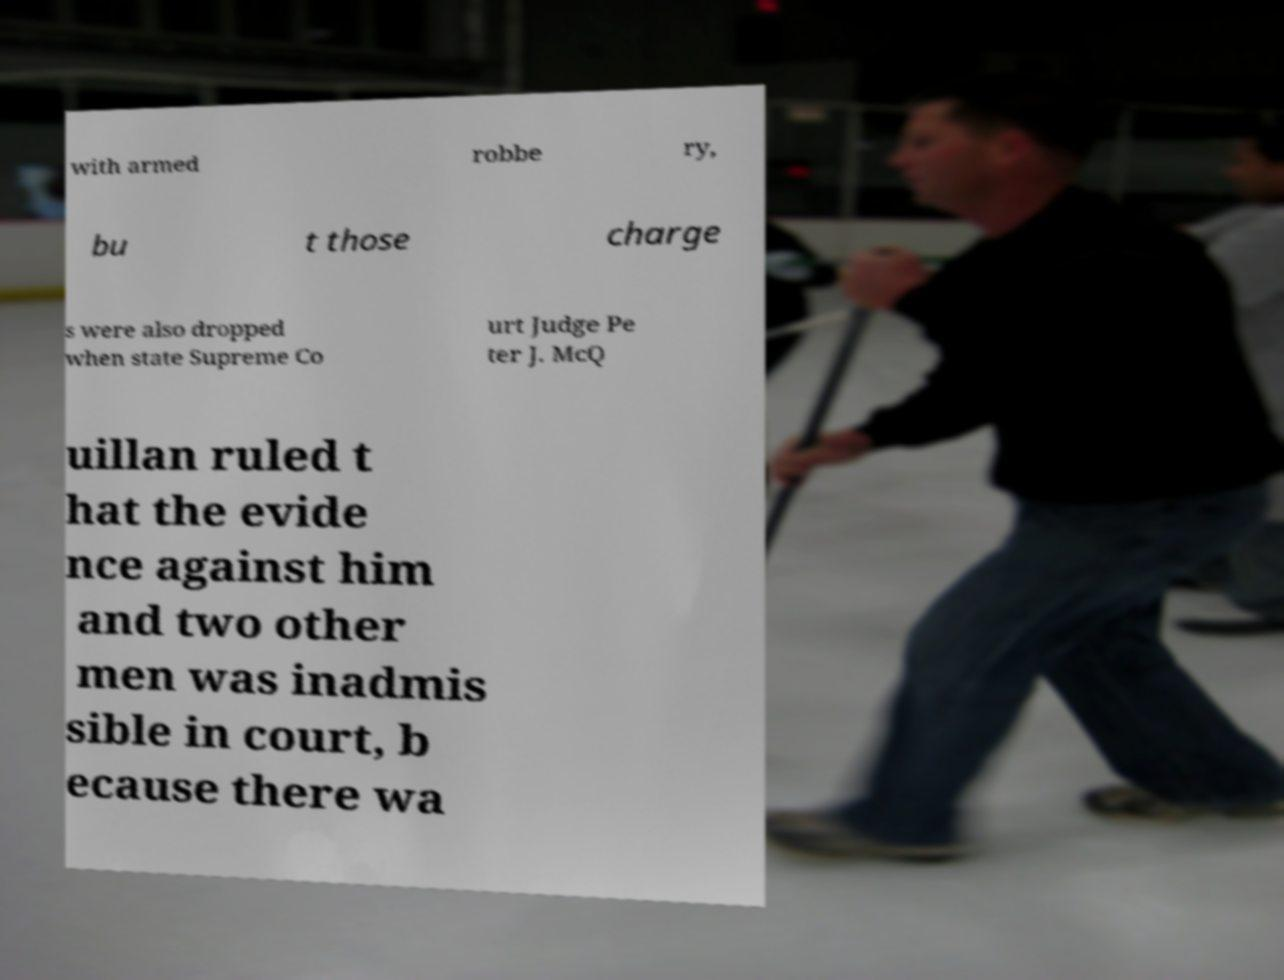Could you assist in decoding the text presented in this image and type it out clearly? with armed robbe ry, bu t those charge s were also dropped when state Supreme Co urt Judge Pe ter J. McQ uillan ruled t hat the evide nce against him and two other men was inadmis sible in court, b ecause there wa 